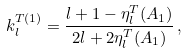<formula> <loc_0><loc_0><loc_500><loc_500>k _ { l } ^ { T ( 1 ) } = \frac { l + 1 - \eta _ { l } ^ { T } ( A _ { 1 } ) } { 2 l + 2 \eta _ { l } ^ { T } ( A _ { 1 } ) } \, ,</formula> 